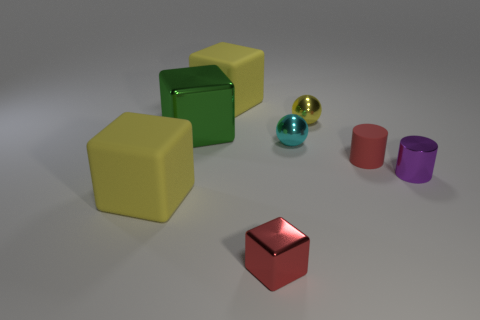What size is the red object that is the same shape as the purple shiny object?
Provide a succinct answer. Small. Are there any other things that have the same size as the purple shiny cylinder?
Your response must be concise. Yes. How many objects are either matte blocks behind the small red cylinder or things that are behind the tiny purple shiny cylinder?
Offer a terse response. 5. Is the green thing the same size as the yellow ball?
Your answer should be very brief. No. Is the number of metal balls greater than the number of blocks?
Give a very brief answer. No. How many other objects are the same color as the small metallic cylinder?
Your response must be concise. 0. How many objects are small purple shiny objects or brown metal objects?
Make the answer very short. 1. There is a red object to the right of the red metallic cube; is its shape the same as the tiny purple object?
Your response must be concise. Yes. The rubber thing that is behind the tiny red thing right of the cyan shiny object is what color?
Provide a short and direct response. Yellow. Are there fewer small purple cylinders than tiny brown blocks?
Ensure brevity in your answer.  No. 